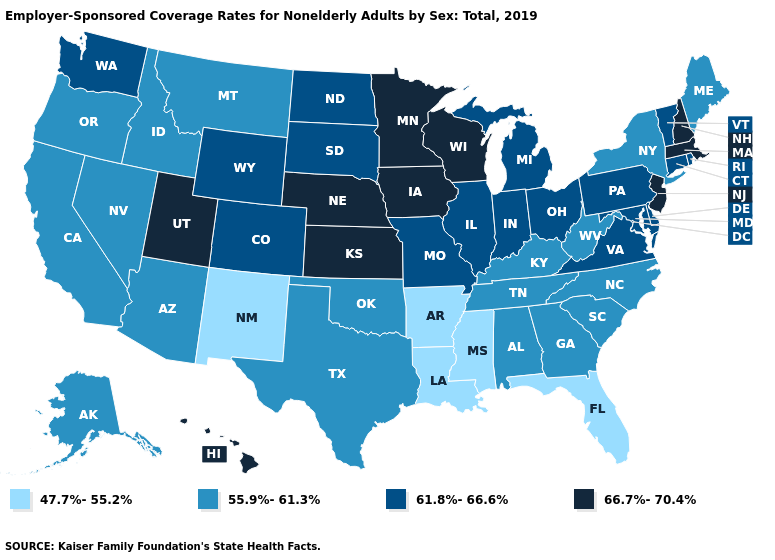What is the value of Minnesota?
Short answer required. 66.7%-70.4%. Does Rhode Island have a lower value than Massachusetts?
Write a very short answer. Yes. Is the legend a continuous bar?
Be succinct. No. What is the value of Utah?
Give a very brief answer. 66.7%-70.4%. Among the states that border New Mexico , does Utah have the highest value?
Give a very brief answer. Yes. What is the value of Nebraska?
Quick response, please. 66.7%-70.4%. Does Ohio have a lower value than South Dakota?
Concise answer only. No. Does Louisiana have the lowest value in the USA?
Answer briefly. Yes. Does the first symbol in the legend represent the smallest category?
Give a very brief answer. Yes. What is the value of Vermont?
Keep it brief. 61.8%-66.6%. Does Texas have a lower value than Virginia?
Answer briefly. Yes. Among the states that border New Jersey , which have the highest value?
Concise answer only. Delaware, Pennsylvania. What is the value of Hawaii?
Answer briefly. 66.7%-70.4%. What is the lowest value in the South?
Write a very short answer. 47.7%-55.2%. Which states have the highest value in the USA?
Concise answer only. Hawaii, Iowa, Kansas, Massachusetts, Minnesota, Nebraska, New Hampshire, New Jersey, Utah, Wisconsin. 